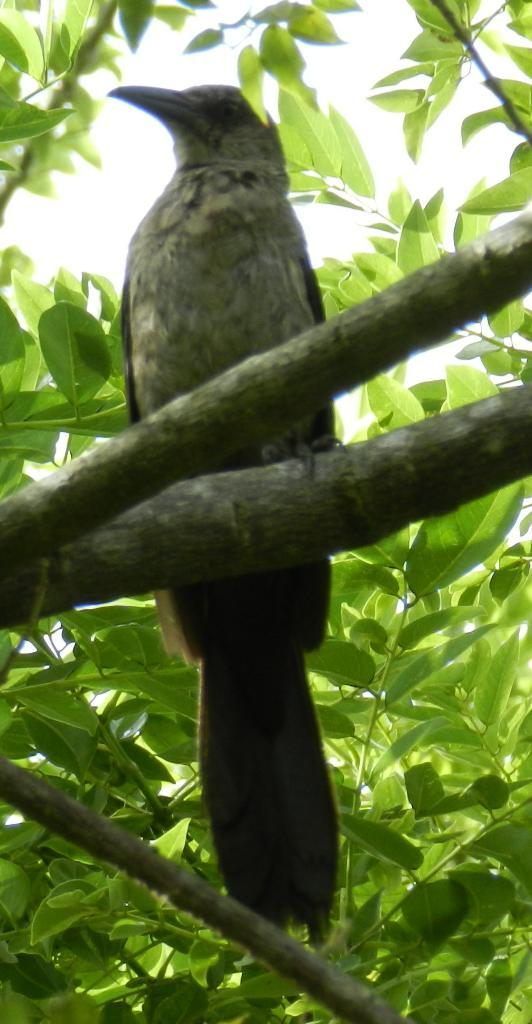What type of animal can be seen in the image? There is a bird in the image. Where is the bird located? The bird is on a tree. What can be seen in the background of the image? There is a sky visible in the background of the image. How many cows are grazing in the field in the image? There are no cows or fields present in the image; it features a bird on a tree with a sky background. 